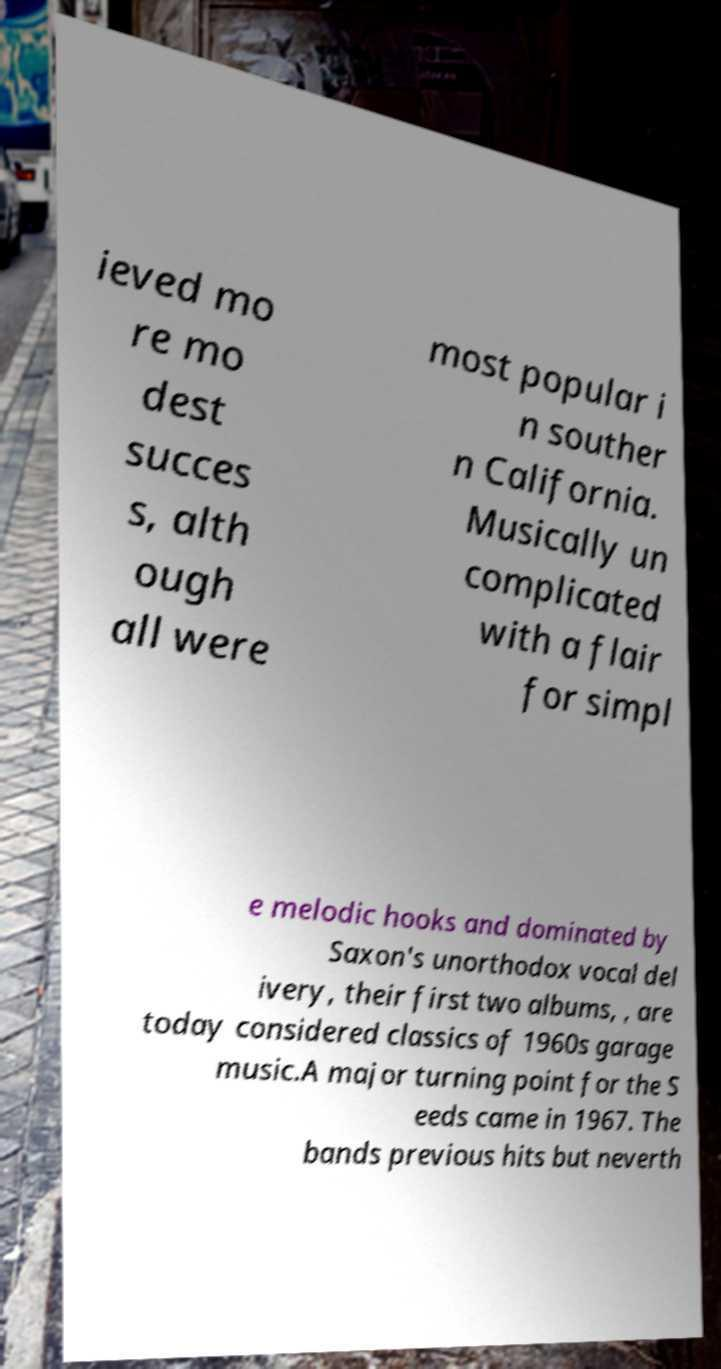Could you extract and type out the text from this image? ieved mo re mo dest succes s, alth ough all were most popular i n souther n California. Musically un complicated with a flair for simpl e melodic hooks and dominated by Saxon's unorthodox vocal del ivery, their first two albums, , are today considered classics of 1960s garage music.A major turning point for the S eeds came in 1967. The bands previous hits but neverth 